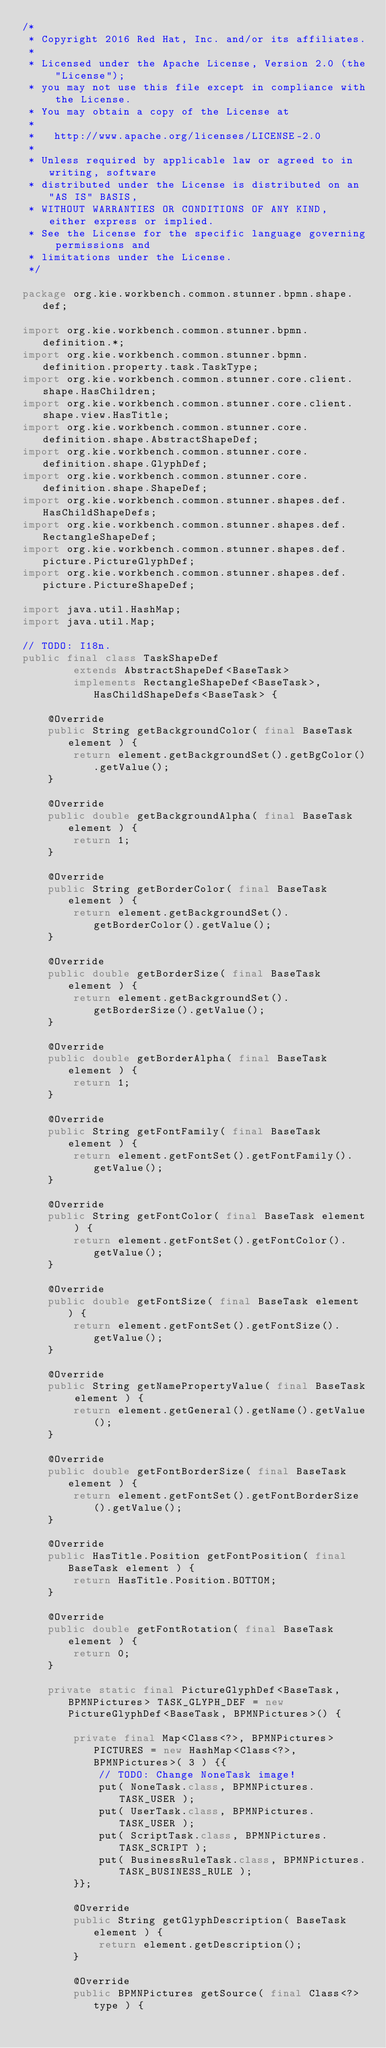<code> <loc_0><loc_0><loc_500><loc_500><_Java_>/*
 * Copyright 2016 Red Hat, Inc. and/or its affiliates.
 *
 * Licensed under the Apache License, Version 2.0 (the "License");
 * you may not use this file except in compliance with the License.
 * You may obtain a copy of the License at
 *
 *   http://www.apache.org/licenses/LICENSE-2.0
 *
 * Unless required by applicable law or agreed to in writing, software
 * distributed under the License is distributed on an "AS IS" BASIS,
 * WITHOUT WARRANTIES OR CONDITIONS OF ANY KIND, either express or implied.
 * See the License for the specific language governing permissions and
 * limitations under the License.
 */

package org.kie.workbench.common.stunner.bpmn.shape.def;

import org.kie.workbench.common.stunner.bpmn.definition.*;
import org.kie.workbench.common.stunner.bpmn.definition.property.task.TaskType;
import org.kie.workbench.common.stunner.core.client.shape.HasChildren;
import org.kie.workbench.common.stunner.core.client.shape.view.HasTitle;
import org.kie.workbench.common.stunner.core.definition.shape.AbstractShapeDef;
import org.kie.workbench.common.stunner.core.definition.shape.GlyphDef;
import org.kie.workbench.common.stunner.core.definition.shape.ShapeDef;
import org.kie.workbench.common.stunner.shapes.def.HasChildShapeDefs;
import org.kie.workbench.common.stunner.shapes.def.RectangleShapeDef;
import org.kie.workbench.common.stunner.shapes.def.picture.PictureGlyphDef;
import org.kie.workbench.common.stunner.shapes.def.picture.PictureShapeDef;

import java.util.HashMap;
import java.util.Map;

// TODO: I18n.
public final class TaskShapeDef
        extends AbstractShapeDef<BaseTask>
        implements RectangleShapeDef<BaseTask>, HasChildShapeDefs<BaseTask> {

    @Override
    public String getBackgroundColor( final BaseTask element ) {
        return element.getBackgroundSet().getBgColor().getValue();
    }

    @Override
    public double getBackgroundAlpha( final BaseTask element ) {
        return 1;
    }

    @Override
    public String getBorderColor( final BaseTask element ) {
        return element.getBackgroundSet().getBorderColor().getValue();
    }

    @Override
    public double getBorderSize( final BaseTask element ) {
        return element.getBackgroundSet().getBorderSize().getValue();
    }

    @Override
    public double getBorderAlpha( final BaseTask element ) {
        return 1;
    }

    @Override
    public String getFontFamily( final BaseTask element ) {
        return element.getFontSet().getFontFamily().getValue();
    }

    @Override
    public String getFontColor( final BaseTask element ) {
        return element.getFontSet().getFontColor().getValue();
    }

    @Override
    public double getFontSize( final BaseTask element ) {
        return element.getFontSet().getFontSize().getValue();
    }

    @Override
    public String getNamePropertyValue( final BaseTask element ) {
        return element.getGeneral().getName().getValue();
    }

    @Override
    public double getFontBorderSize( final BaseTask element ) {
        return element.getFontSet().getFontBorderSize().getValue();
    }

    @Override
    public HasTitle.Position getFontPosition( final BaseTask element ) {
        return HasTitle.Position.BOTTOM;
    }

    @Override
    public double getFontRotation( final BaseTask element ) {
        return 0;
    }

    private static final PictureGlyphDef<BaseTask, BPMNPictures> TASK_GLYPH_DEF = new PictureGlyphDef<BaseTask, BPMNPictures>() {

        private final Map<Class<?>, BPMNPictures> PICTURES = new HashMap<Class<?>, BPMNPictures>( 3 ) {{
            // TODO: Change NoneTask image!
            put( NoneTask.class, BPMNPictures.TASK_USER );
            put( UserTask.class, BPMNPictures.TASK_USER );
            put( ScriptTask.class, BPMNPictures.TASK_SCRIPT );
            put( BusinessRuleTask.class, BPMNPictures.TASK_BUSINESS_RULE );
        }};

        @Override
        public String getGlyphDescription( BaseTask element ) {
            return element.getDescription();
        }

        @Override
        public BPMNPictures getSource( final Class<?> type ) {</code> 